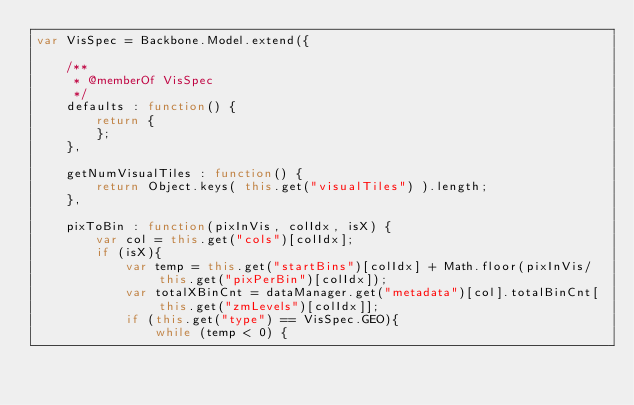<code> <loc_0><loc_0><loc_500><loc_500><_JavaScript_>var VisSpec = Backbone.Model.extend({
		
	/**
	 * @memberOf VisSpec
	 */
	defaults : function() {
		return {
		};
	},
	
	getNumVisualTiles : function() {
		return Object.keys( this.get("visualTiles") ).length;
	}, 

	pixToBin : function(pixInVis, colIdx, isX) {
		var col = this.get("cols")[colIdx];
		if (isX){
			var temp = this.get("startBins")[colIdx] + Math.floor(pixInVis/this.get("pixPerBin")[colIdx]);
			var totalXBinCnt = dataManager.get("metadata")[col].totalBinCnt[this.get("zmLevels")[colIdx]];
			if (this.get("type") == VisSpec.GEO){
				while (temp < 0) {</code> 